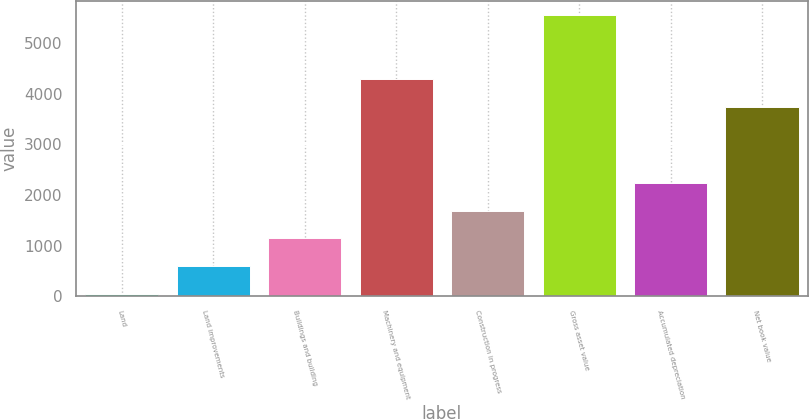<chart> <loc_0><loc_0><loc_500><loc_500><bar_chart><fcel>Land<fcel>Land improvements<fcel>Buildings and building<fcel>Machinery and equipment<fcel>Construction in progress<fcel>Gross asset value<fcel>Accumulated depreciation<fcel>Net book value<nl><fcel>42<fcel>592.7<fcel>1143.4<fcel>4283.7<fcel>1694.1<fcel>5549<fcel>2244.8<fcel>3733<nl></chart> 